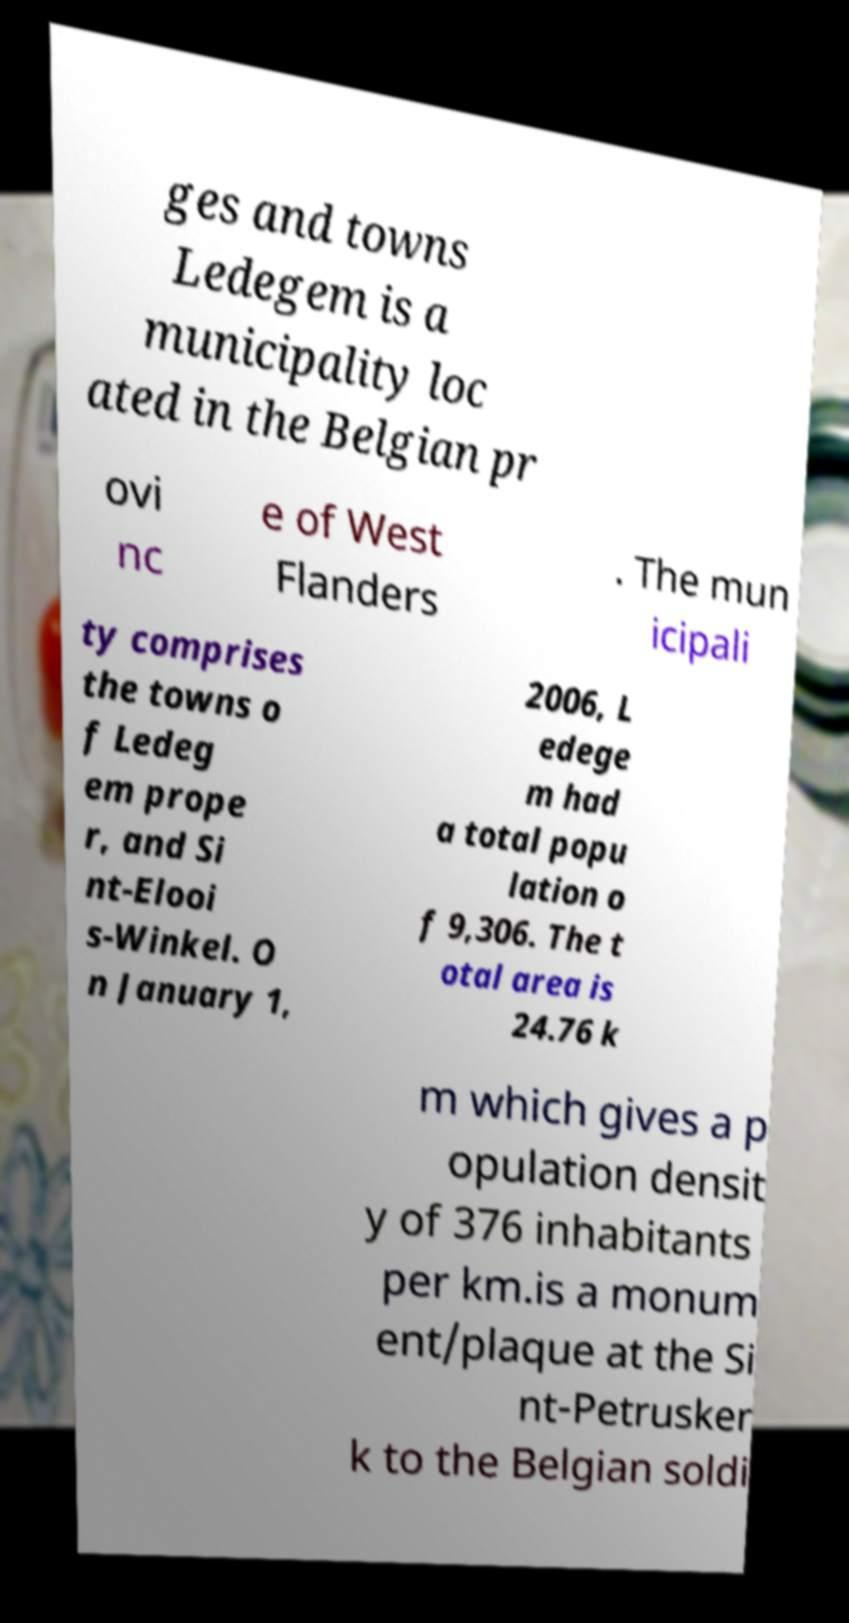Could you extract and type out the text from this image? ges and towns Ledegem is a municipality loc ated in the Belgian pr ovi nc e of West Flanders . The mun icipali ty comprises the towns o f Ledeg em prope r, and Si nt-Elooi s-Winkel. O n January 1, 2006, L edege m had a total popu lation o f 9,306. The t otal area is 24.76 k m which gives a p opulation densit y of 376 inhabitants per km.is a monum ent/plaque at the Si nt-Petrusker k to the Belgian soldi 